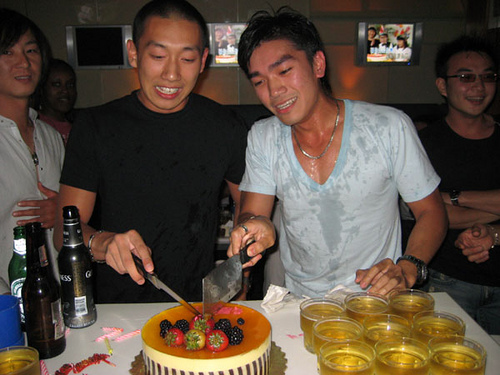Are there fruits on the cake? Yes, there are various fruits topping the cake, such as strawberries, blackberries, and kiwi slices. 